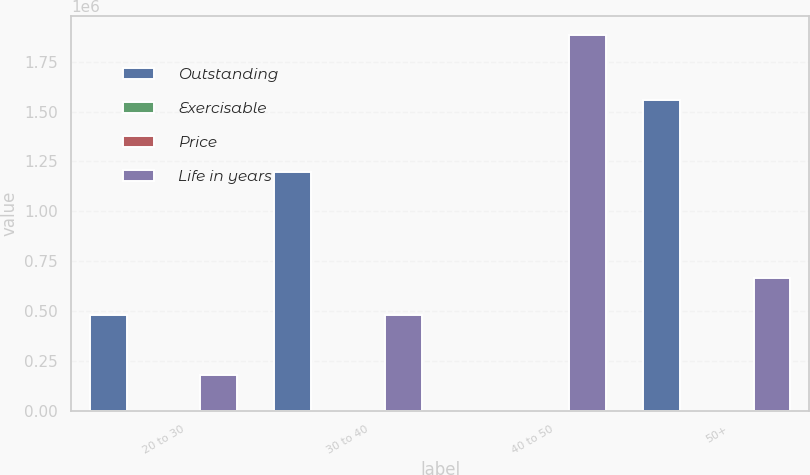<chart> <loc_0><loc_0><loc_500><loc_500><stacked_bar_chart><ecel><fcel>20 to 30<fcel>30 to 40<fcel>40 to 50<fcel>50+<nl><fcel>Outstanding<fcel>480573<fcel>1.19769e+06<fcel>56.54<fcel>1.56e+06<nl><fcel>Exercisable<fcel>5.6<fcel>7.6<fcel>5.5<fcel>7.6<nl><fcel>Price<fcel>26.74<fcel>39.6<fcel>44.62<fcel>56.54<nl><fcel>Life in years<fcel>180573<fcel>480164<fcel>1.88458e+06<fcel>665800<nl></chart> 